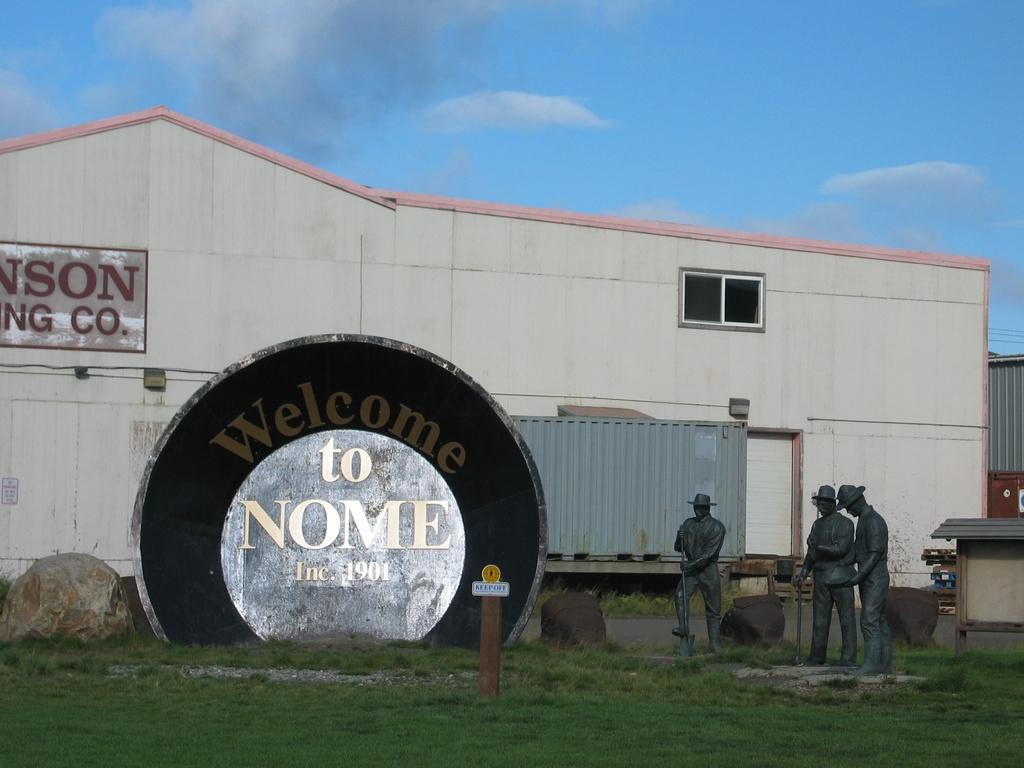What type of vegetation can be seen in the image? There is grass in the image. What type of structures are present in the image? There are buildings in the image. What type of artwork is visible in the image? There are sculptures of people in the image. What type of text or symbols can be seen in the image? There is writing visible in the image. What can be seen in the background of the image? There are clouds and the sky visible in the background of the image. What type of string is being used to hold up the poison in the image? There is no string or poison present in the image. How many markets are visible in the image? There are no markets visible in the image. 